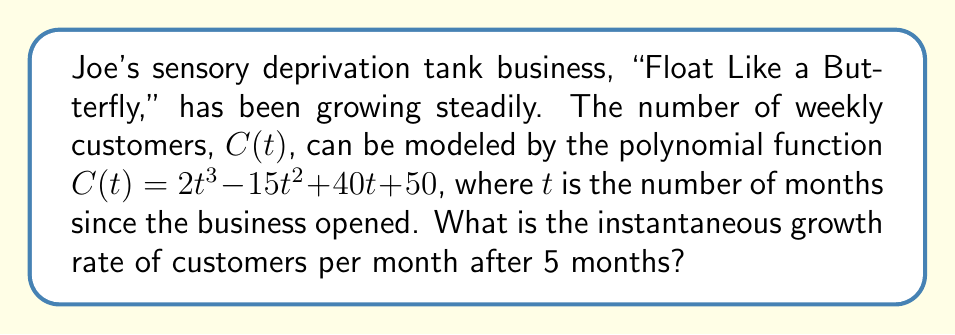Give your solution to this math problem. To find the instantaneous growth rate after 5 months, we need to find the derivative of the function $C(t)$ and evaluate it at $t=5$. This process involves the following steps:

1) The given function is $C(t) = 2t^3 - 15t^2 + 40t + 50$

2) To find the derivative, we apply the power rule and constant rule:
   $$C'(t) = 6t^2 - 30t + 40$$

3) This derivative function, $C'(t)$, represents the instantaneous growth rate at any time $t$.

4) To find the growth rate at 5 months, we substitute $t=5$ into $C'(t)$:

   $$C'(5) = 6(5^2) - 30(5) + 40$$
   $$= 6(25) - 150 + 40$$
   $$= 150 - 150 + 40$$
   $$= 40$$

Therefore, after 5 months, the instantaneous growth rate is 40 customers per month.
Answer: 40 customers per month 